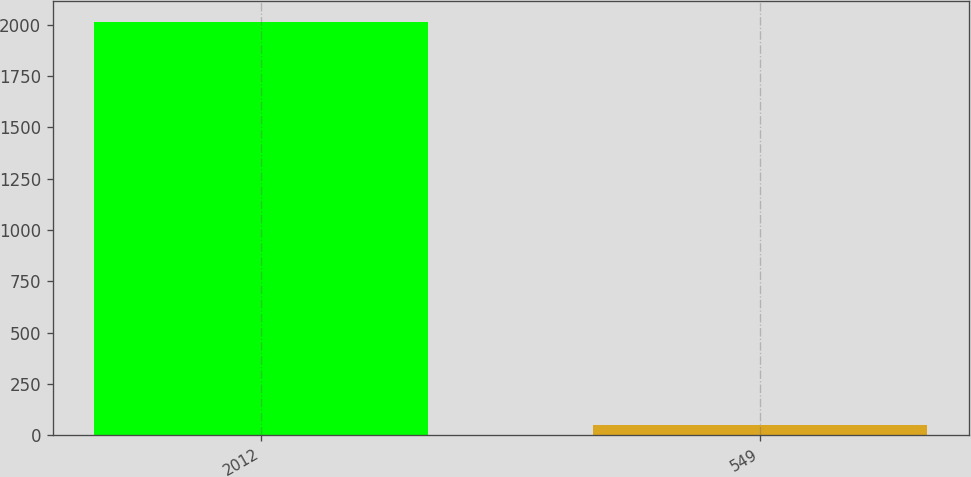Convert chart to OTSL. <chart><loc_0><loc_0><loc_500><loc_500><bar_chart><fcel>2012<fcel>549<nl><fcel>2014<fcel>48.3<nl></chart> 